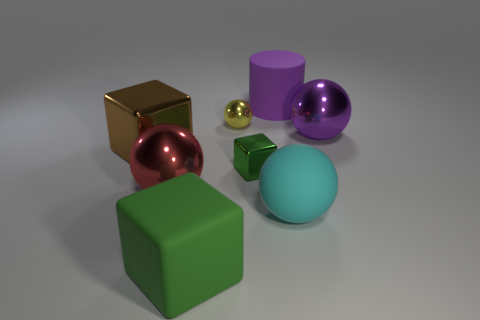How many objects are balls that are behind the cyan thing or large cubes right of the red sphere?
Provide a succinct answer. 4. Is there a tiny sphere to the right of the metallic block that is right of the large green thing?
Give a very brief answer. No. What shape is the green object that is the same size as the cyan thing?
Ensure brevity in your answer.  Cube. What number of objects are tiny objects that are in front of the large purple metal ball or small cyan matte objects?
Offer a terse response. 1. How many other things are there of the same material as the big purple cylinder?
Keep it short and to the point. 2. There is a small shiny object that is the same color as the rubber block; what shape is it?
Make the answer very short. Cube. How big is the sphere that is left of the yellow shiny thing?
Ensure brevity in your answer.  Large. There is a large purple object that is the same material as the cyan ball; what is its shape?
Provide a succinct answer. Cylinder. Do the red sphere and the big cube that is behind the big matte block have the same material?
Your response must be concise. Yes. Is the shape of the small shiny object right of the yellow ball the same as  the large green rubber object?
Offer a very short reply. Yes. 